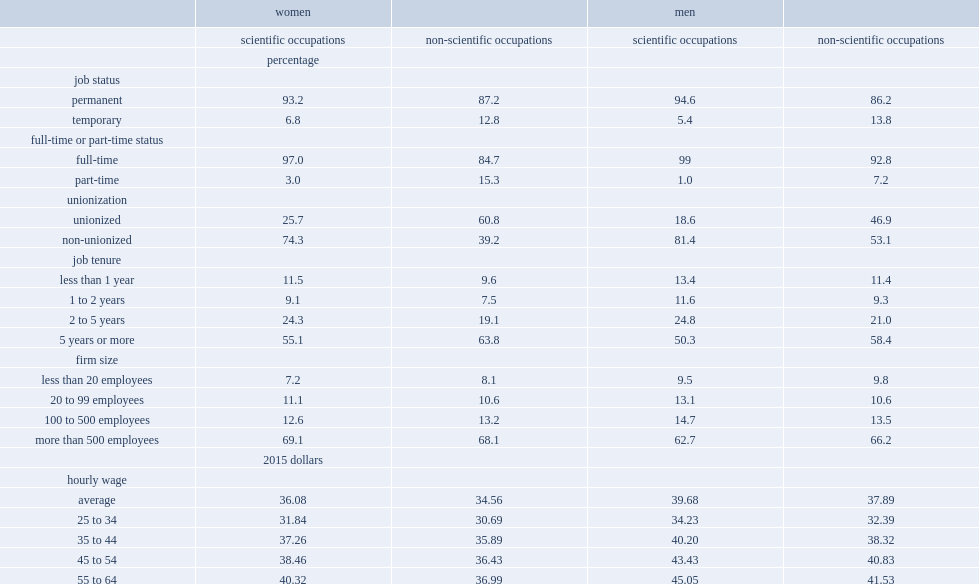Which group of women was more likely to have a permanent position, to work full time and to have higher hourly wages, women who worked in scientific occupations or women who worked in non-scientific occupations? Scientific occupations. Which group of women was less likely to be unionized, women in scientific occupations or women in non-scientific occupations? Scientific occupations. Which group of men was less likely to be unionized, men in scientific occupations or men in non-scientific occupations? Scientific occupations. 